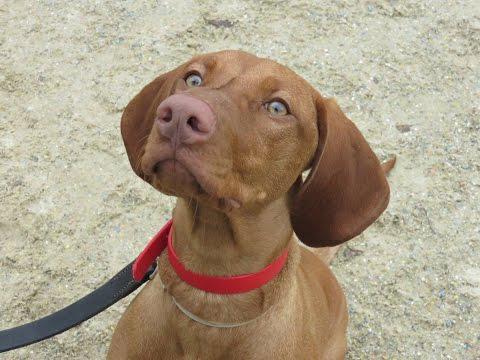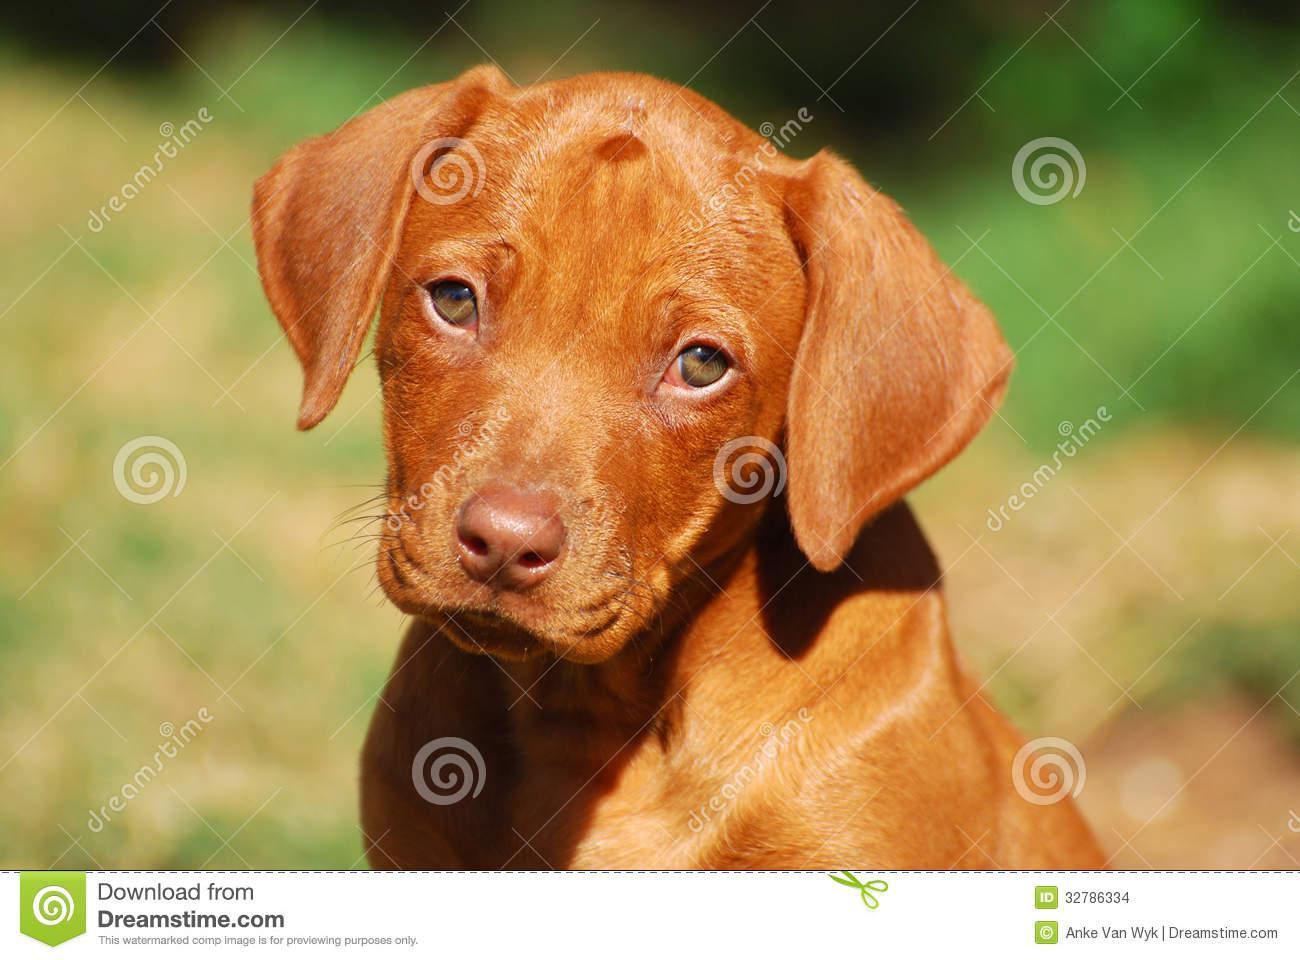The first image is the image on the left, the second image is the image on the right. Analyze the images presented: Is the assertion "The dog on the left is wearing a brightly colored, clearly visible collar, while the dog on the right is seemingly not wearing a collar or anything else around it's neck." valid? Answer yes or no. Yes. The first image is the image on the left, the second image is the image on the right. Evaluate the accuracy of this statement regarding the images: "The left image features a close-mouthed dog in a collar gazing up and to the left, and the right image features a puppy with a wrinkly mouth.". Is it true? Answer yes or no. Yes. 